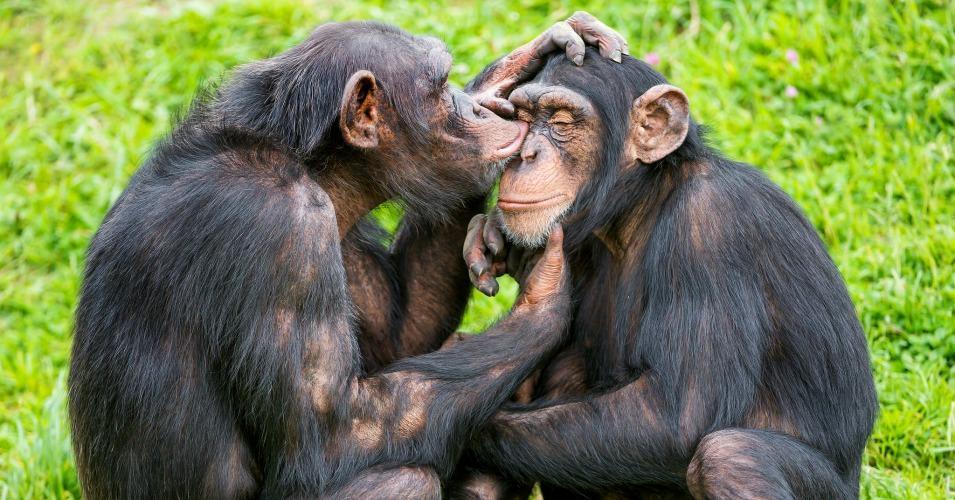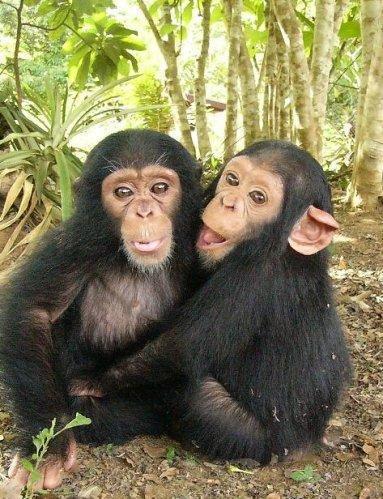The first image is the image on the left, the second image is the image on the right. Examine the images to the left and right. Is the description "One chimpanzee is touching another chimpanzee with both its hands." accurate? Answer yes or no. Yes. The first image is the image on the left, the second image is the image on the right. Considering the images on both sides, is "There are four chimpanzees." valid? Answer yes or no. Yes. 